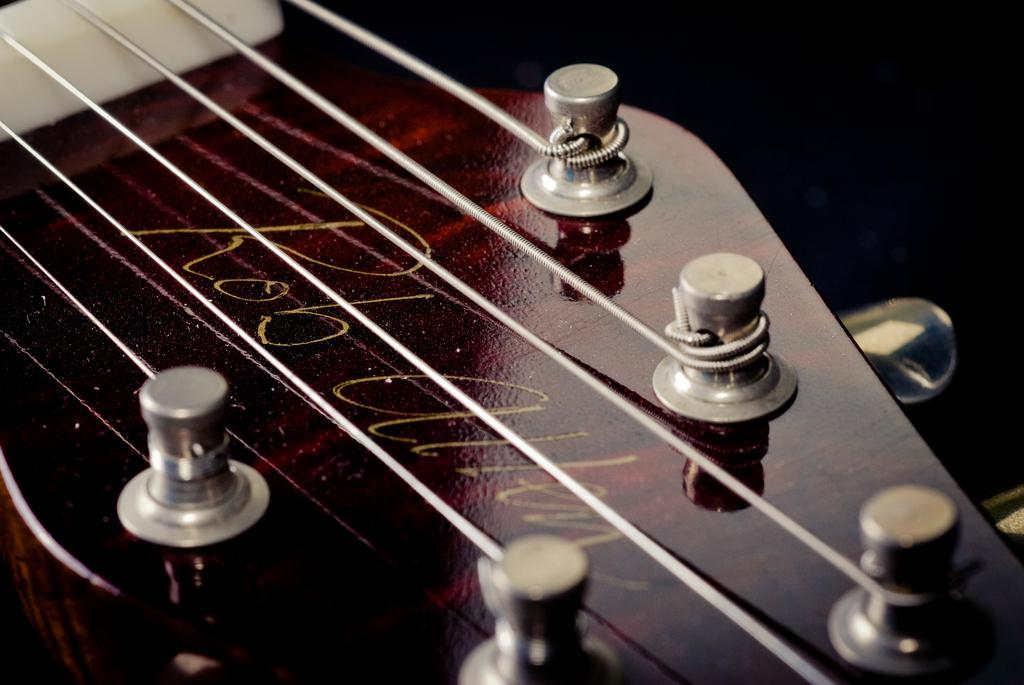What musical instrument is featured in the image? The strings of a guitar are visible in the image. Can you describe the specific part of the guitar that is shown? The strings of the guitar are visible in the image. What type of agreement is being discussed in the image? There is no discussion or agreement present in the image; it features the strings of a guitar. What verse or lyrics can be seen written on the guitar in the image? There are no verses or lyrics visible on the guitar in the image; only the strings are present. 